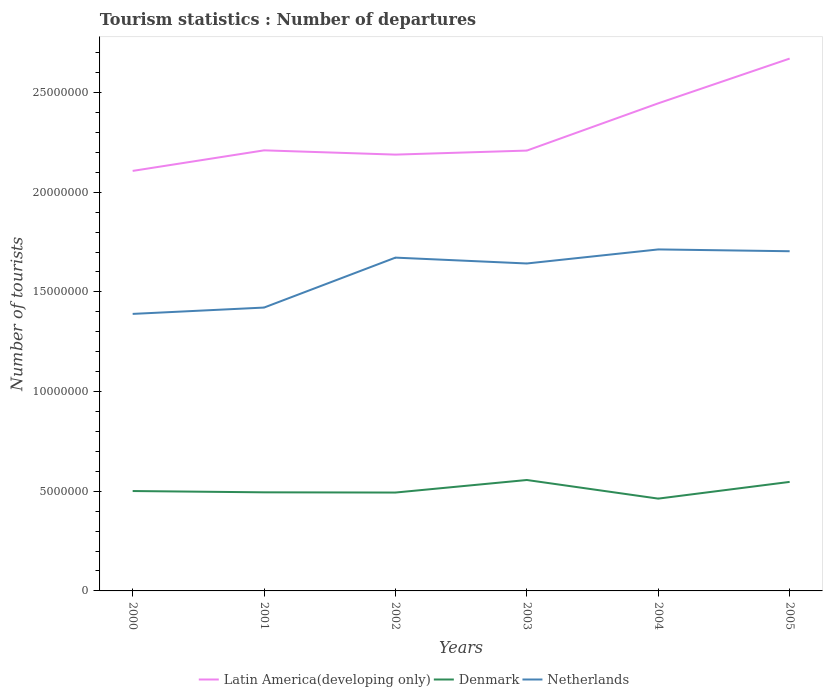How many different coloured lines are there?
Give a very brief answer. 3. Is the number of lines equal to the number of legend labels?
Give a very brief answer. Yes. Across all years, what is the maximum number of tourist departures in Denmark?
Your answer should be very brief. 4.63e+06. In which year was the number of tourist departures in Netherlands maximum?
Provide a succinct answer. 2000. What is the total number of tourist departures in Denmark in the graph?
Offer a very short reply. 9.34e+05. What is the difference between the highest and the second highest number of tourist departures in Netherlands?
Your answer should be compact. 3.23e+06. What is the difference between the highest and the lowest number of tourist departures in Denmark?
Provide a short and direct response. 2. How many lines are there?
Make the answer very short. 3. How many years are there in the graph?
Your response must be concise. 6. Are the values on the major ticks of Y-axis written in scientific E-notation?
Your response must be concise. No. Does the graph contain grids?
Offer a terse response. No. Where does the legend appear in the graph?
Provide a short and direct response. Bottom center. How many legend labels are there?
Offer a very short reply. 3. How are the legend labels stacked?
Your response must be concise. Horizontal. What is the title of the graph?
Provide a short and direct response. Tourism statistics : Number of departures. What is the label or title of the X-axis?
Make the answer very short. Years. What is the label or title of the Y-axis?
Offer a very short reply. Number of tourists. What is the Number of tourists of Latin America(developing only) in 2000?
Give a very brief answer. 2.11e+07. What is the Number of tourists in Denmark in 2000?
Provide a short and direct response. 5.01e+06. What is the Number of tourists in Netherlands in 2000?
Make the answer very short. 1.39e+07. What is the Number of tourists in Latin America(developing only) in 2001?
Your answer should be very brief. 2.21e+07. What is the Number of tourists of Denmark in 2001?
Give a very brief answer. 4.95e+06. What is the Number of tourists in Netherlands in 2001?
Ensure brevity in your answer.  1.42e+07. What is the Number of tourists in Latin America(developing only) in 2002?
Provide a succinct answer. 2.19e+07. What is the Number of tourists in Denmark in 2002?
Ensure brevity in your answer.  4.94e+06. What is the Number of tourists of Netherlands in 2002?
Your answer should be very brief. 1.67e+07. What is the Number of tourists in Latin America(developing only) in 2003?
Your answer should be compact. 2.21e+07. What is the Number of tourists in Denmark in 2003?
Keep it short and to the point. 5.56e+06. What is the Number of tourists in Netherlands in 2003?
Your response must be concise. 1.64e+07. What is the Number of tourists in Latin America(developing only) in 2004?
Provide a short and direct response. 2.45e+07. What is the Number of tourists in Denmark in 2004?
Keep it short and to the point. 4.63e+06. What is the Number of tourists of Netherlands in 2004?
Provide a succinct answer. 1.71e+07. What is the Number of tourists in Latin America(developing only) in 2005?
Your response must be concise. 2.67e+07. What is the Number of tourists in Denmark in 2005?
Your answer should be very brief. 5.47e+06. What is the Number of tourists in Netherlands in 2005?
Your answer should be very brief. 1.70e+07. Across all years, what is the maximum Number of tourists of Latin America(developing only)?
Provide a succinct answer. 2.67e+07. Across all years, what is the maximum Number of tourists in Denmark?
Keep it short and to the point. 5.56e+06. Across all years, what is the maximum Number of tourists of Netherlands?
Make the answer very short. 1.71e+07. Across all years, what is the minimum Number of tourists in Latin America(developing only)?
Provide a succinct answer. 2.11e+07. Across all years, what is the minimum Number of tourists in Denmark?
Ensure brevity in your answer.  4.63e+06. Across all years, what is the minimum Number of tourists in Netherlands?
Make the answer very short. 1.39e+07. What is the total Number of tourists in Latin America(developing only) in the graph?
Your answer should be compact. 1.38e+08. What is the total Number of tourists in Denmark in the graph?
Provide a short and direct response. 3.06e+07. What is the total Number of tourists of Netherlands in the graph?
Keep it short and to the point. 9.54e+07. What is the difference between the Number of tourists of Latin America(developing only) in 2000 and that in 2001?
Your response must be concise. -1.03e+06. What is the difference between the Number of tourists of Denmark in 2000 and that in 2001?
Your response must be concise. 6.50e+04. What is the difference between the Number of tourists in Netherlands in 2000 and that in 2001?
Ensure brevity in your answer.  -3.18e+05. What is the difference between the Number of tourists in Latin America(developing only) in 2000 and that in 2002?
Give a very brief answer. -8.18e+05. What is the difference between the Number of tourists in Denmark in 2000 and that in 2002?
Make the answer very short. 7.60e+04. What is the difference between the Number of tourists in Netherlands in 2000 and that in 2002?
Offer a very short reply. -2.82e+06. What is the difference between the Number of tourists in Latin America(developing only) in 2000 and that in 2003?
Your response must be concise. -1.02e+06. What is the difference between the Number of tourists of Denmark in 2000 and that in 2003?
Offer a very short reply. -5.53e+05. What is the difference between the Number of tourists in Netherlands in 2000 and that in 2003?
Provide a short and direct response. -2.53e+06. What is the difference between the Number of tourists of Latin America(developing only) in 2000 and that in 2004?
Provide a succinct answer. -3.39e+06. What is the difference between the Number of tourists in Denmark in 2000 and that in 2004?
Offer a terse response. 3.81e+05. What is the difference between the Number of tourists of Netherlands in 2000 and that in 2004?
Your answer should be very brief. -3.23e+06. What is the difference between the Number of tourists of Latin America(developing only) in 2000 and that in 2005?
Provide a succinct answer. -5.63e+06. What is the difference between the Number of tourists in Denmark in 2000 and that in 2005?
Your answer should be very brief. -4.58e+05. What is the difference between the Number of tourists in Netherlands in 2000 and that in 2005?
Give a very brief answer. -3.14e+06. What is the difference between the Number of tourists in Latin America(developing only) in 2001 and that in 2002?
Provide a short and direct response. 2.13e+05. What is the difference between the Number of tourists in Denmark in 2001 and that in 2002?
Provide a succinct answer. 1.10e+04. What is the difference between the Number of tourists of Netherlands in 2001 and that in 2002?
Ensure brevity in your answer.  -2.50e+06. What is the difference between the Number of tourists in Latin America(developing only) in 2001 and that in 2003?
Your answer should be compact. 1.13e+04. What is the difference between the Number of tourists in Denmark in 2001 and that in 2003?
Keep it short and to the point. -6.18e+05. What is the difference between the Number of tourists of Netherlands in 2001 and that in 2003?
Give a very brief answer. -2.21e+06. What is the difference between the Number of tourists in Latin America(developing only) in 2001 and that in 2004?
Ensure brevity in your answer.  -2.36e+06. What is the difference between the Number of tourists in Denmark in 2001 and that in 2004?
Provide a succinct answer. 3.16e+05. What is the difference between the Number of tourists in Netherlands in 2001 and that in 2004?
Your response must be concise. -2.92e+06. What is the difference between the Number of tourists in Latin America(developing only) in 2001 and that in 2005?
Your response must be concise. -4.60e+06. What is the difference between the Number of tourists of Denmark in 2001 and that in 2005?
Ensure brevity in your answer.  -5.23e+05. What is the difference between the Number of tourists of Netherlands in 2001 and that in 2005?
Provide a short and direct response. -2.82e+06. What is the difference between the Number of tourists of Latin America(developing only) in 2002 and that in 2003?
Offer a terse response. -2.02e+05. What is the difference between the Number of tourists of Denmark in 2002 and that in 2003?
Provide a succinct answer. -6.29e+05. What is the difference between the Number of tourists of Netherlands in 2002 and that in 2003?
Keep it short and to the point. 2.94e+05. What is the difference between the Number of tourists of Latin America(developing only) in 2002 and that in 2004?
Make the answer very short. -2.57e+06. What is the difference between the Number of tourists in Denmark in 2002 and that in 2004?
Ensure brevity in your answer.  3.05e+05. What is the difference between the Number of tourists of Netherlands in 2002 and that in 2004?
Give a very brief answer. -4.11e+05. What is the difference between the Number of tourists of Latin America(developing only) in 2002 and that in 2005?
Offer a terse response. -4.82e+06. What is the difference between the Number of tourists in Denmark in 2002 and that in 2005?
Provide a succinct answer. -5.34e+05. What is the difference between the Number of tourists in Netherlands in 2002 and that in 2005?
Provide a short and direct response. -3.20e+05. What is the difference between the Number of tourists in Latin America(developing only) in 2003 and that in 2004?
Give a very brief answer. -2.37e+06. What is the difference between the Number of tourists in Denmark in 2003 and that in 2004?
Make the answer very short. 9.34e+05. What is the difference between the Number of tourists of Netherlands in 2003 and that in 2004?
Provide a short and direct response. -7.05e+05. What is the difference between the Number of tourists in Latin America(developing only) in 2003 and that in 2005?
Your answer should be compact. -4.61e+06. What is the difference between the Number of tourists in Denmark in 2003 and that in 2005?
Keep it short and to the point. 9.50e+04. What is the difference between the Number of tourists in Netherlands in 2003 and that in 2005?
Your response must be concise. -6.14e+05. What is the difference between the Number of tourists in Latin America(developing only) in 2004 and that in 2005?
Provide a succinct answer. -2.24e+06. What is the difference between the Number of tourists of Denmark in 2004 and that in 2005?
Keep it short and to the point. -8.39e+05. What is the difference between the Number of tourists of Netherlands in 2004 and that in 2005?
Provide a succinct answer. 9.10e+04. What is the difference between the Number of tourists in Latin America(developing only) in 2000 and the Number of tourists in Denmark in 2001?
Offer a terse response. 1.61e+07. What is the difference between the Number of tourists of Latin America(developing only) in 2000 and the Number of tourists of Netherlands in 2001?
Keep it short and to the point. 6.85e+06. What is the difference between the Number of tourists in Denmark in 2000 and the Number of tourists in Netherlands in 2001?
Your answer should be very brief. -9.20e+06. What is the difference between the Number of tourists of Latin America(developing only) in 2000 and the Number of tourists of Denmark in 2002?
Ensure brevity in your answer.  1.61e+07. What is the difference between the Number of tourists of Latin America(developing only) in 2000 and the Number of tourists of Netherlands in 2002?
Your answer should be compact. 4.35e+06. What is the difference between the Number of tourists in Denmark in 2000 and the Number of tourists in Netherlands in 2002?
Ensure brevity in your answer.  -1.17e+07. What is the difference between the Number of tourists in Latin America(developing only) in 2000 and the Number of tourists in Denmark in 2003?
Offer a terse response. 1.55e+07. What is the difference between the Number of tourists of Latin America(developing only) in 2000 and the Number of tourists of Netherlands in 2003?
Your answer should be compact. 4.64e+06. What is the difference between the Number of tourists in Denmark in 2000 and the Number of tourists in Netherlands in 2003?
Provide a succinct answer. -1.14e+07. What is the difference between the Number of tourists in Latin America(developing only) in 2000 and the Number of tourists in Denmark in 2004?
Your response must be concise. 1.64e+07. What is the difference between the Number of tourists of Latin America(developing only) in 2000 and the Number of tourists of Netherlands in 2004?
Offer a terse response. 3.94e+06. What is the difference between the Number of tourists in Denmark in 2000 and the Number of tourists in Netherlands in 2004?
Keep it short and to the point. -1.21e+07. What is the difference between the Number of tourists in Latin America(developing only) in 2000 and the Number of tourists in Denmark in 2005?
Your answer should be very brief. 1.56e+07. What is the difference between the Number of tourists in Latin America(developing only) in 2000 and the Number of tourists in Netherlands in 2005?
Offer a very short reply. 4.03e+06. What is the difference between the Number of tourists of Denmark in 2000 and the Number of tourists of Netherlands in 2005?
Provide a short and direct response. -1.20e+07. What is the difference between the Number of tourists in Latin America(developing only) in 2001 and the Number of tourists in Denmark in 2002?
Keep it short and to the point. 1.72e+07. What is the difference between the Number of tourists of Latin America(developing only) in 2001 and the Number of tourists of Netherlands in 2002?
Offer a terse response. 5.38e+06. What is the difference between the Number of tourists in Denmark in 2001 and the Number of tourists in Netherlands in 2002?
Your answer should be compact. -1.18e+07. What is the difference between the Number of tourists of Latin America(developing only) in 2001 and the Number of tourists of Denmark in 2003?
Give a very brief answer. 1.65e+07. What is the difference between the Number of tourists in Latin America(developing only) in 2001 and the Number of tourists in Netherlands in 2003?
Provide a succinct answer. 5.67e+06. What is the difference between the Number of tourists in Denmark in 2001 and the Number of tourists in Netherlands in 2003?
Ensure brevity in your answer.  -1.15e+07. What is the difference between the Number of tourists of Latin America(developing only) in 2001 and the Number of tourists of Denmark in 2004?
Make the answer very short. 1.75e+07. What is the difference between the Number of tourists in Latin America(developing only) in 2001 and the Number of tourists in Netherlands in 2004?
Offer a terse response. 4.97e+06. What is the difference between the Number of tourists in Denmark in 2001 and the Number of tourists in Netherlands in 2004?
Provide a short and direct response. -1.22e+07. What is the difference between the Number of tourists in Latin America(developing only) in 2001 and the Number of tourists in Denmark in 2005?
Your response must be concise. 1.66e+07. What is the difference between the Number of tourists of Latin America(developing only) in 2001 and the Number of tourists of Netherlands in 2005?
Keep it short and to the point. 5.06e+06. What is the difference between the Number of tourists in Denmark in 2001 and the Number of tourists in Netherlands in 2005?
Ensure brevity in your answer.  -1.21e+07. What is the difference between the Number of tourists in Latin America(developing only) in 2002 and the Number of tourists in Denmark in 2003?
Your response must be concise. 1.63e+07. What is the difference between the Number of tourists in Latin America(developing only) in 2002 and the Number of tourists in Netherlands in 2003?
Provide a short and direct response. 5.46e+06. What is the difference between the Number of tourists of Denmark in 2002 and the Number of tourists of Netherlands in 2003?
Keep it short and to the point. -1.15e+07. What is the difference between the Number of tourists of Latin America(developing only) in 2002 and the Number of tourists of Denmark in 2004?
Ensure brevity in your answer.  1.73e+07. What is the difference between the Number of tourists in Latin America(developing only) in 2002 and the Number of tourists in Netherlands in 2004?
Your answer should be compact. 4.76e+06. What is the difference between the Number of tourists in Denmark in 2002 and the Number of tourists in Netherlands in 2004?
Your response must be concise. -1.22e+07. What is the difference between the Number of tourists of Latin America(developing only) in 2002 and the Number of tourists of Denmark in 2005?
Offer a very short reply. 1.64e+07. What is the difference between the Number of tourists in Latin America(developing only) in 2002 and the Number of tourists in Netherlands in 2005?
Offer a very short reply. 4.85e+06. What is the difference between the Number of tourists in Denmark in 2002 and the Number of tourists in Netherlands in 2005?
Keep it short and to the point. -1.21e+07. What is the difference between the Number of tourists in Latin America(developing only) in 2003 and the Number of tourists in Denmark in 2004?
Ensure brevity in your answer.  1.75e+07. What is the difference between the Number of tourists in Latin America(developing only) in 2003 and the Number of tourists in Netherlands in 2004?
Offer a terse response. 4.96e+06. What is the difference between the Number of tourists in Denmark in 2003 and the Number of tourists in Netherlands in 2004?
Provide a short and direct response. -1.16e+07. What is the difference between the Number of tourists of Latin America(developing only) in 2003 and the Number of tourists of Denmark in 2005?
Offer a very short reply. 1.66e+07. What is the difference between the Number of tourists in Latin America(developing only) in 2003 and the Number of tourists in Netherlands in 2005?
Your answer should be compact. 5.05e+06. What is the difference between the Number of tourists in Denmark in 2003 and the Number of tourists in Netherlands in 2005?
Ensure brevity in your answer.  -1.15e+07. What is the difference between the Number of tourists in Latin America(developing only) in 2004 and the Number of tourists in Denmark in 2005?
Make the answer very short. 1.90e+07. What is the difference between the Number of tourists of Latin America(developing only) in 2004 and the Number of tourists of Netherlands in 2005?
Give a very brief answer. 7.42e+06. What is the difference between the Number of tourists in Denmark in 2004 and the Number of tourists in Netherlands in 2005?
Ensure brevity in your answer.  -1.24e+07. What is the average Number of tourists in Latin America(developing only) per year?
Provide a short and direct response. 2.31e+07. What is the average Number of tourists in Denmark per year?
Offer a terse response. 5.09e+06. What is the average Number of tourists in Netherlands per year?
Offer a very short reply. 1.59e+07. In the year 2000, what is the difference between the Number of tourists of Latin America(developing only) and Number of tourists of Denmark?
Keep it short and to the point. 1.61e+07. In the year 2000, what is the difference between the Number of tourists of Latin America(developing only) and Number of tourists of Netherlands?
Offer a terse response. 7.17e+06. In the year 2000, what is the difference between the Number of tourists in Denmark and Number of tourists in Netherlands?
Ensure brevity in your answer.  -8.88e+06. In the year 2001, what is the difference between the Number of tourists in Latin America(developing only) and Number of tourists in Denmark?
Give a very brief answer. 1.72e+07. In the year 2001, what is the difference between the Number of tourists of Latin America(developing only) and Number of tourists of Netherlands?
Offer a very short reply. 7.89e+06. In the year 2001, what is the difference between the Number of tourists in Denmark and Number of tourists in Netherlands?
Your answer should be very brief. -9.27e+06. In the year 2002, what is the difference between the Number of tourists in Latin America(developing only) and Number of tourists in Denmark?
Give a very brief answer. 1.70e+07. In the year 2002, what is the difference between the Number of tourists in Latin America(developing only) and Number of tourists in Netherlands?
Offer a very short reply. 5.17e+06. In the year 2002, what is the difference between the Number of tourists of Denmark and Number of tourists of Netherlands?
Your answer should be compact. -1.18e+07. In the year 2003, what is the difference between the Number of tourists of Latin America(developing only) and Number of tourists of Denmark?
Make the answer very short. 1.65e+07. In the year 2003, what is the difference between the Number of tourists in Latin America(developing only) and Number of tourists in Netherlands?
Ensure brevity in your answer.  5.66e+06. In the year 2003, what is the difference between the Number of tourists of Denmark and Number of tourists of Netherlands?
Your answer should be very brief. -1.09e+07. In the year 2004, what is the difference between the Number of tourists in Latin America(developing only) and Number of tourists in Denmark?
Your response must be concise. 1.98e+07. In the year 2004, what is the difference between the Number of tourists of Latin America(developing only) and Number of tourists of Netherlands?
Provide a short and direct response. 7.33e+06. In the year 2004, what is the difference between the Number of tourists of Denmark and Number of tourists of Netherlands?
Give a very brief answer. -1.25e+07. In the year 2005, what is the difference between the Number of tourists of Latin America(developing only) and Number of tourists of Denmark?
Give a very brief answer. 2.12e+07. In the year 2005, what is the difference between the Number of tourists in Latin America(developing only) and Number of tourists in Netherlands?
Your answer should be very brief. 9.66e+06. In the year 2005, what is the difference between the Number of tourists in Denmark and Number of tourists in Netherlands?
Your answer should be compact. -1.16e+07. What is the ratio of the Number of tourists in Latin America(developing only) in 2000 to that in 2001?
Your answer should be very brief. 0.95. What is the ratio of the Number of tourists in Denmark in 2000 to that in 2001?
Make the answer very short. 1.01. What is the ratio of the Number of tourists of Netherlands in 2000 to that in 2001?
Your answer should be compact. 0.98. What is the ratio of the Number of tourists of Latin America(developing only) in 2000 to that in 2002?
Offer a terse response. 0.96. What is the ratio of the Number of tourists of Denmark in 2000 to that in 2002?
Keep it short and to the point. 1.02. What is the ratio of the Number of tourists in Netherlands in 2000 to that in 2002?
Offer a very short reply. 0.83. What is the ratio of the Number of tourists in Latin America(developing only) in 2000 to that in 2003?
Make the answer very short. 0.95. What is the ratio of the Number of tourists of Denmark in 2000 to that in 2003?
Provide a succinct answer. 0.9. What is the ratio of the Number of tourists of Netherlands in 2000 to that in 2003?
Make the answer very short. 0.85. What is the ratio of the Number of tourists of Latin America(developing only) in 2000 to that in 2004?
Make the answer very short. 0.86. What is the ratio of the Number of tourists of Denmark in 2000 to that in 2004?
Your answer should be very brief. 1.08. What is the ratio of the Number of tourists in Netherlands in 2000 to that in 2004?
Your response must be concise. 0.81. What is the ratio of the Number of tourists of Latin America(developing only) in 2000 to that in 2005?
Your answer should be very brief. 0.79. What is the ratio of the Number of tourists in Denmark in 2000 to that in 2005?
Provide a succinct answer. 0.92. What is the ratio of the Number of tourists of Netherlands in 2000 to that in 2005?
Your answer should be compact. 0.82. What is the ratio of the Number of tourists in Latin America(developing only) in 2001 to that in 2002?
Your answer should be very brief. 1.01. What is the ratio of the Number of tourists in Denmark in 2001 to that in 2002?
Your answer should be very brief. 1. What is the ratio of the Number of tourists in Netherlands in 2001 to that in 2002?
Your response must be concise. 0.85. What is the ratio of the Number of tourists of Latin America(developing only) in 2001 to that in 2003?
Provide a succinct answer. 1. What is the ratio of the Number of tourists in Netherlands in 2001 to that in 2003?
Ensure brevity in your answer.  0.87. What is the ratio of the Number of tourists in Latin America(developing only) in 2001 to that in 2004?
Provide a short and direct response. 0.9. What is the ratio of the Number of tourists in Denmark in 2001 to that in 2004?
Provide a succinct answer. 1.07. What is the ratio of the Number of tourists of Netherlands in 2001 to that in 2004?
Make the answer very short. 0.83. What is the ratio of the Number of tourists of Latin America(developing only) in 2001 to that in 2005?
Offer a very short reply. 0.83. What is the ratio of the Number of tourists of Denmark in 2001 to that in 2005?
Keep it short and to the point. 0.9. What is the ratio of the Number of tourists of Netherlands in 2001 to that in 2005?
Give a very brief answer. 0.83. What is the ratio of the Number of tourists of Latin America(developing only) in 2002 to that in 2003?
Give a very brief answer. 0.99. What is the ratio of the Number of tourists of Denmark in 2002 to that in 2003?
Offer a terse response. 0.89. What is the ratio of the Number of tourists in Netherlands in 2002 to that in 2003?
Make the answer very short. 1.02. What is the ratio of the Number of tourists of Latin America(developing only) in 2002 to that in 2004?
Ensure brevity in your answer.  0.89. What is the ratio of the Number of tourists of Denmark in 2002 to that in 2004?
Keep it short and to the point. 1.07. What is the ratio of the Number of tourists of Latin America(developing only) in 2002 to that in 2005?
Provide a short and direct response. 0.82. What is the ratio of the Number of tourists of Denmark in 2002 to that in 2005?
Provide a short and direct response. 0.9. What is the ratio of the Number of tourists of Netherlands in 2002 to that in 2005?
Your answer should be compact. 0.98. What is the ratio of the Number of tourists in Latin America(developing only) in 2003 to that in 2004?
Your answer should be very brief. 0.9. What is the ratio of the Number of tourists of Denmark in 2003 to that in 2004?
Ensure brevity in your answer.  1.2. What is the ratio of the Number of tourists of Netherlands in 2003 to that in 2004?
Offer a terse response. 0.96. What is the ratio of the Number of tourists in Latin America(developing only) in 2003 to that in 2005?
Provide a succinct answer. 0.83. What is the ratio of the Number of tourists of Denmark in 2003 to that in 2005?
Your answer should be compact. 1.02. What is the ratio of the Number of tourists in Netherlands in 2003 to that in 2005?
Provide a short and direct response. 0.96. What is the ratio of the Number of tourists in Latin America(developing only) in 2004 to that in 2005?
Offer a very short reply. 0.92. What is the ratio of the Number of tourists in Denmark in 2004 to that in 2005?
Provide a short and direct response. 0.85. What is the difference between the highest and the second highest Number of tourists of Latin America(developing only)?
Your answer should be compact. 2.24e+06. What is the difference between the highest and the second highest Number of tourists in Denmark?
Give a very brief answer. 9.50e+04. What is the difference between the highest and the second highest Number of tourists in Netherlands?
Your response must be concise. 9.10e+04. What is the difference between the highest and the lowest Number of tourists in Latin America(developing only)?
Your answer should be very brief. 5.63e+06. What is the difference between the highest and the lowest Number of tourists of Denmark?
Provide a succinct answer. 9.34e+05. What is the difference between the highest and the lowest Number of tourists of Netherlands?
Offer a terse response. 3.23e+06. 